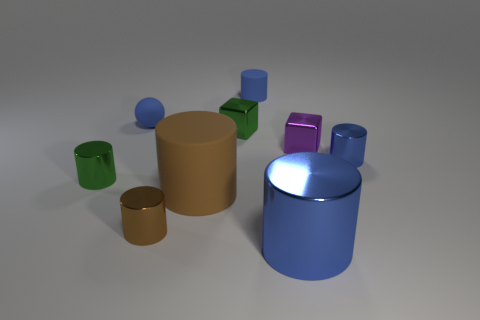Which objects look like they might be the heaviest and why? Based on their size and assuming they are all made of the same material, the large blue and brown cylinders seem like they would be the heaviest due to their volume. 